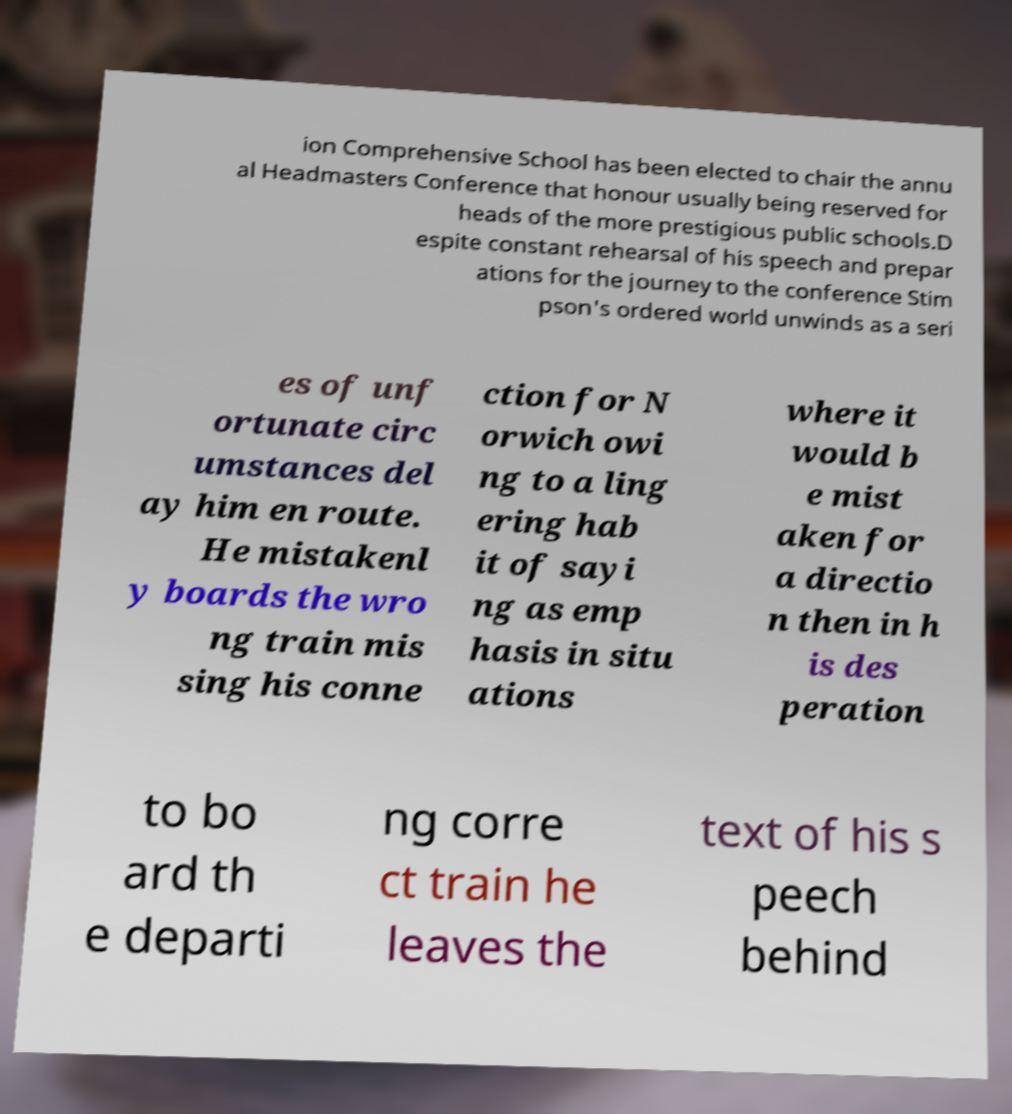I need the written content from this picture converted into text. Can you do that? ion Comprehensive School has been elected to chair the annu al Headmasters Conference that honour usually being reserved for heads of the more prestigious public schools.D espite constant rehearsal of his speech and prepar ations for the journey to the conference Stim pson's ordered world unwinds as a seri es of unf ortunate circ umstances del ay him en route. He mistakenl y boards the wro ng train mis sing his conne ction for N orwich owi ng to a ling ering hab it of sayi ng as emp hasis in situ ations where it would b e mist aken for a directio n then in h is des peration to bo ard th e departi ng corre ct train he leaves the text of his s peech behind 